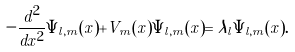Convert formula to latex. <formula><loc_0><loc_0><loc_500><loc_500>- \frac { d ^ { 2 } } { d x ^ { 2 } } \Psi _ { l , m } ( x ) + V _ { m } ( x ) \Psi _ { l , m } ( x ) = \lambda _ { l } \Psi _ { l , m } ( x ) .</formula> 